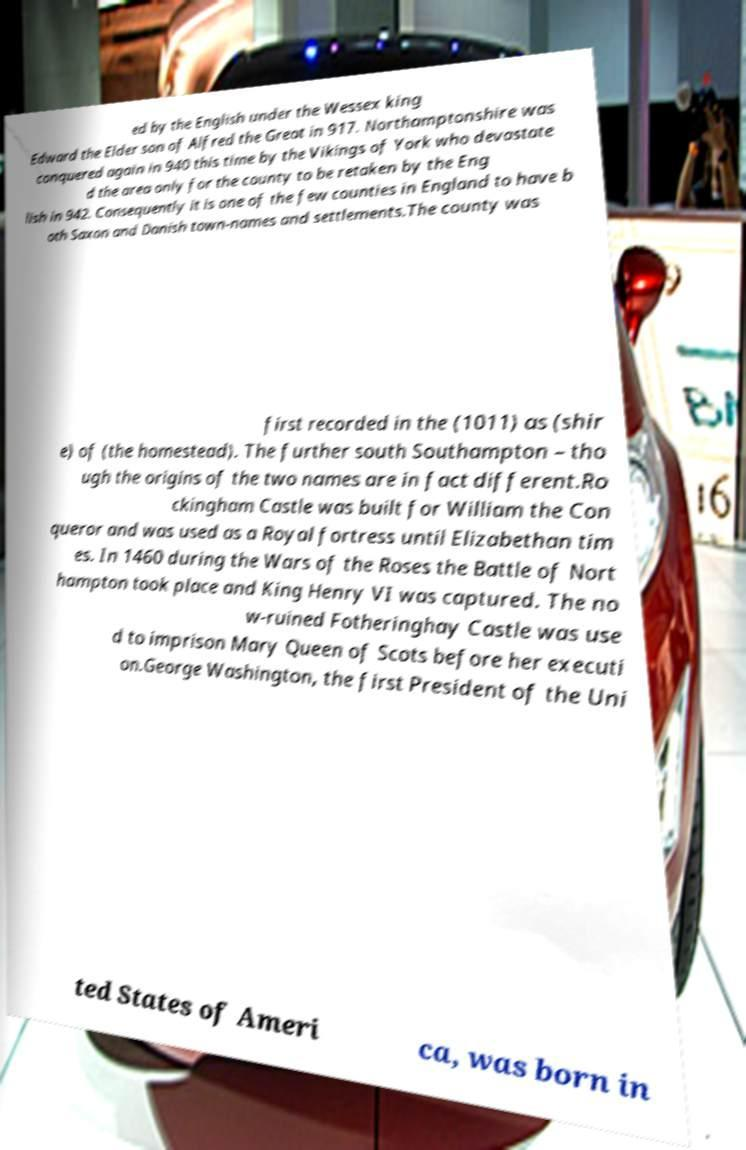Can you accurately transcribe the text from the provided image for me? ed by the English under the Wessex king Edward the Elder son of Alfred the Great in 917. Northamptonshire was conquered again in 940 this time by the Vikings of York who devastate d the area only for the county to be retaken by the Eng lish in 942. Consequently it is one of the few counties in England to have b oth Saxon and Danish town-names and settlements.The county was first recorded in the (1011) as (shir e) of (the homestead). The further south Southampton – tho ugh the origins of the two names are in fact different.Ro ckingham Castle was built for William the Con queror and was used as a Royal fortress until Elizabethan tim es. In 1460 during the Wars of the Roses the Battle of Nort hampton took place and King Henry VI was captured. The no w-ruined Fotheringhay Castle was use d to imprison Mary Queen of Scots before her executi on.George Washington, the first President of the Uni ted States of Ameri ca, was born in 